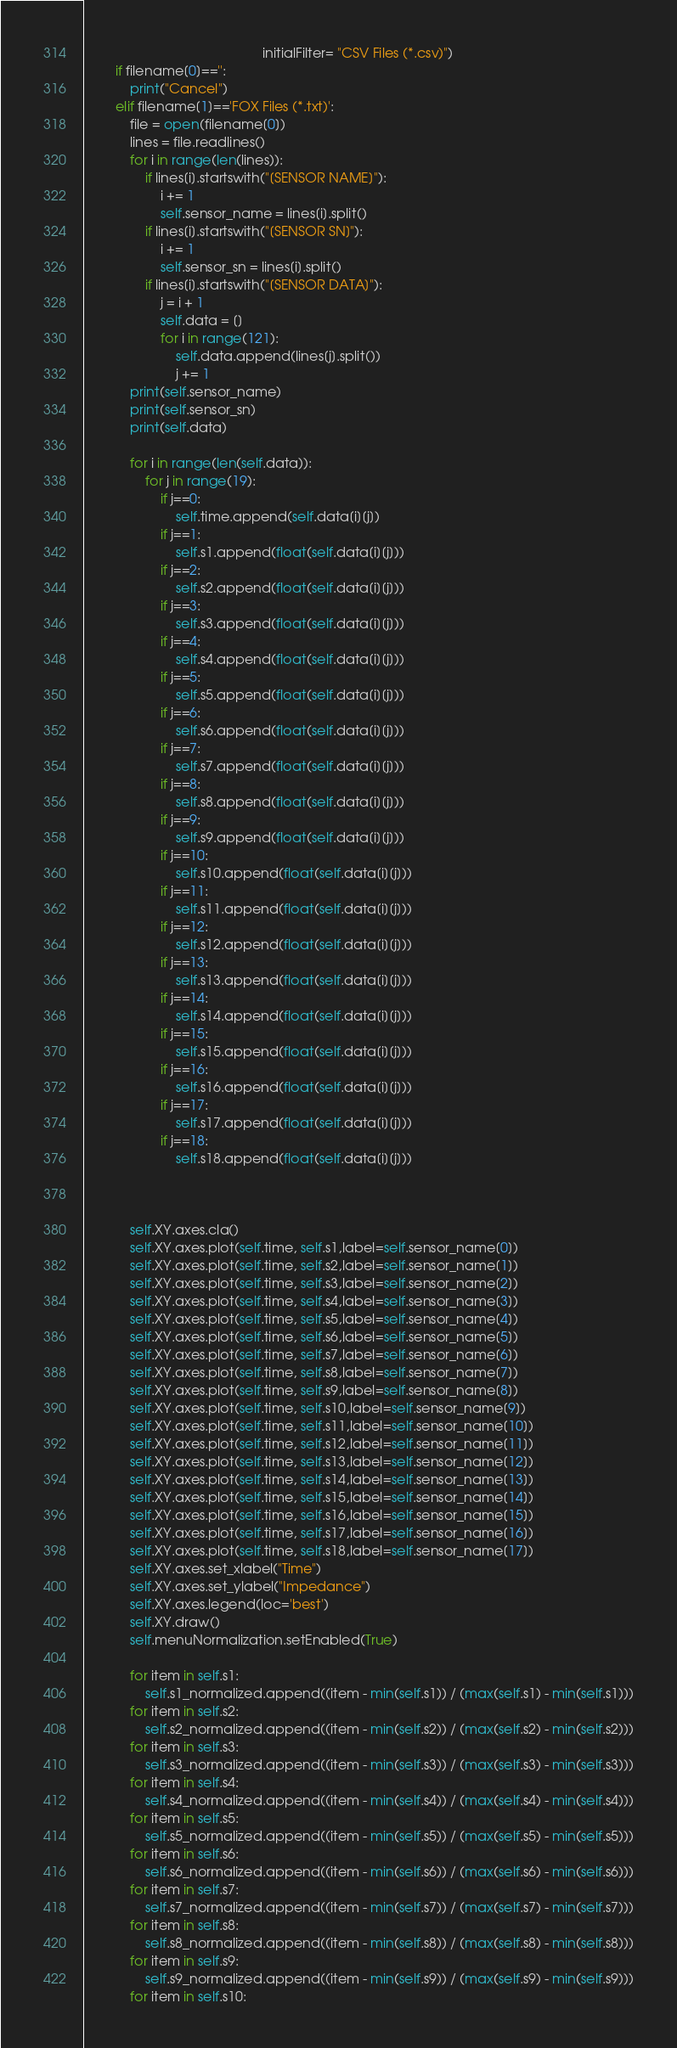<code> <loc_0><loc_0><loc_500><loc_500><_Python_>                                               initialFilter= "CSV Files (*.csv)")
        if filename[0]=='':
            print("Cancel")
        elif filename[1]=='FOX Files (*.txt)':
            file = open(filename[0])
            lines = file.readlines()
            for i in range(len(lines)):
                if lines[i].startswith("[SENSOR NAME]"):
                    i += 1
                    self.sensor_name = lines[i].split()
                if lines[i].startswith("[SENSOR SN]"):
                    i += 1
                    self.sensor_sn = lines[i].split()
                if lines[i].startswith("[SENSOR DATA]"):
                    j = i + 1
                    self.data = []
                    for i in range(121):
                        self.data.append(lines[j].split())
                        j += 1
            print(self.sensor_name)
            print(self.sensor_sn)
            print(self.data)

            for i in range(len(self.data)):
                for j in range(19):
                    if j==0:
                        self.time.append(self.data[i][j])
                    if j==1:
                        self.s1.append(float(self.data[i][j]))
                    if j==2:
                        self.s2.append(float(self.data[i][j]))
                    if j==3:
                        self.s3.append(float(self.data[i][j]))
                    if j==4:
                        self.s4.append(float(self.data[i][j]))
                    if j==5:
                        self.s5.append(float(self.data[i][j]))
                    if j==6:
                        self.s6.append(float(self.data[i][j]))
                    if j==7:
                        self.s7.append(float(self.data[i][j]))
                    if j==8:
                        self.s8.append(float(self.data[i][j]))
                    if j==9:
                        self.s9.append(float(self.data[i][j]))
                    if j==10:
                        self.s10.append(float(self.data[i][j]))
                    if j==11:
                        self.s11.append(float(self.data[i][j]))
                    if j==12:
                        self.s12.append(float(self.data[i][j]))
                    if j==13:
                        self.s13.append(float(self.data[i][j]))
                    if j==14:
                        self.s14.append(float(self.data[i][j]))
                    if j==15:
                        self.s15.append(float(self.data[i][j]))
                    if j==16:
                        self.s16.append(float(self.data[i][j]))
                    if j==17:
                        self.s17.append(float(self.data[i][j]))
                    if j==18:
                        self.s18.append(float(self.data[i][j]))



            self.XY.axes.cla()
            self.XY.axes.plot(self.time, self.s1,label=self.sensor_name[0])
            self.XY.axes.plot(self.time, self.s2,label=self.sensor_name[1])
            self.XY.axes.plot(self.time, self.s3,label=self.sensor_name[2])
            self.XY.axes.plot(self.time, self.s4,label=self.sensor_name[3])
            self.XY.axes.plot(self.time, self.s5,label=self.sensor_name[4])
            self.XY.axes.plot(self.time, self.s6,label=self.sensor_name[5])
            self.XY.axes.plot(self.time, self.s7,label=self.sensor_name[6])
            self.XY.axes.plot(self.time, self.s8,label=self.sensor_name[7])
            self.XY.axes.plot(self.time, self.s9,label=self.sensor_name[8])
            self.XY.axes.plot(self.time, self.s10,label=self.sensor_name[9])
            self.XY.axes.plot(self.time, self.s11,label=self.sensor_name[10])
            self.XY.axes.plot(self.time, self.s12,label=self.sensor_name[11])
            self.XY.axes.plot(self.time, self.s13,label=self.sensor_name[12])
            self.XY.axes.plot(self.time, self.s14,label=self.sensor_name[13])
            self.XY.axes.plot(self.time, self.s15,label=self.sensor_name[14])
            self.XY.axes.plot(self.time, self.s16,label=self.sensor_name[15])
            self.XY.axes.plot(self.time, self.s17,label=self.sensor_name[16])
            self.XY.axes.plot(self.time, self.s18,label=self.sensor_name[17])
            self.XY.axes.set_xlabel("Time")
            self.XY.axes.set_ylabel("Impedance")
            self.XY.axes.legend(loc='best')
            self.XY.draw()
            self.menuNormalization.setEnabled(True)

            for item in self.s1:
                self.s1_normalized.append((item - min(self.s1)) / (max(self.s1) - min(self.s1)))
            for item in self.s2:
                self.s2_normalized.append((item - min(self.s2)) / (max(self.s2) - min(self.s2)))
            for item in self.s3:
                self.s3_normalized.append((item - min(self.s3)) / (max(self.s3) - min(self.s3)))
            for item in self.s4:
                self.s4_normalized.append((item - min(self.s4)) / (max(self.s4) - min(self.s4)))
            for item in self.s5:
                self.s5_normalized.append((item - min(self.s5)) / (max(self.s5) - min(self.s5)))
            for item in self.s6:
                self.s6_normalized.append((item - min(self.s6)) / (max(self.s6) - min(self.s6)))
            for item in self.s7:
                self.s7_normalized.append((item - min(self.s7)) / (max(self.s7) - min(self.s7)))
            for item in self.s8:
                self.s8_normalized.append((item - min(self.s8)) / (max(self.s8) - min(self.s8)))
            for item in self.s9:
                self.s9_normalized.append((item - min(self.s9)) / (max(self.s9) - min(self.s9)))
            for item in self.s10:</code> 